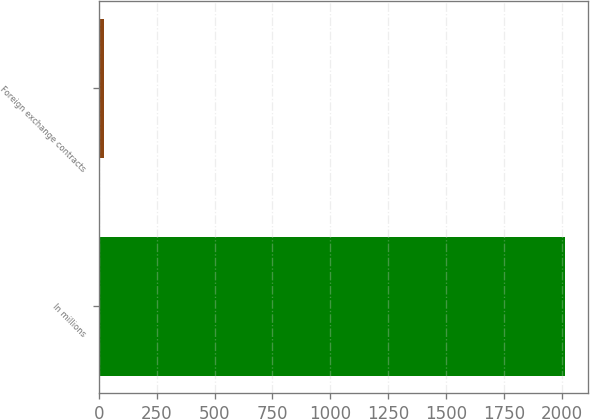Convert chart. <chart><loc_0><loc_0><loc_500><loc_500><bar_chart><fcel>In millions<fcel>Foreign exchange contracts<nl><fcel>2013<fcel>21<nl></chart> 